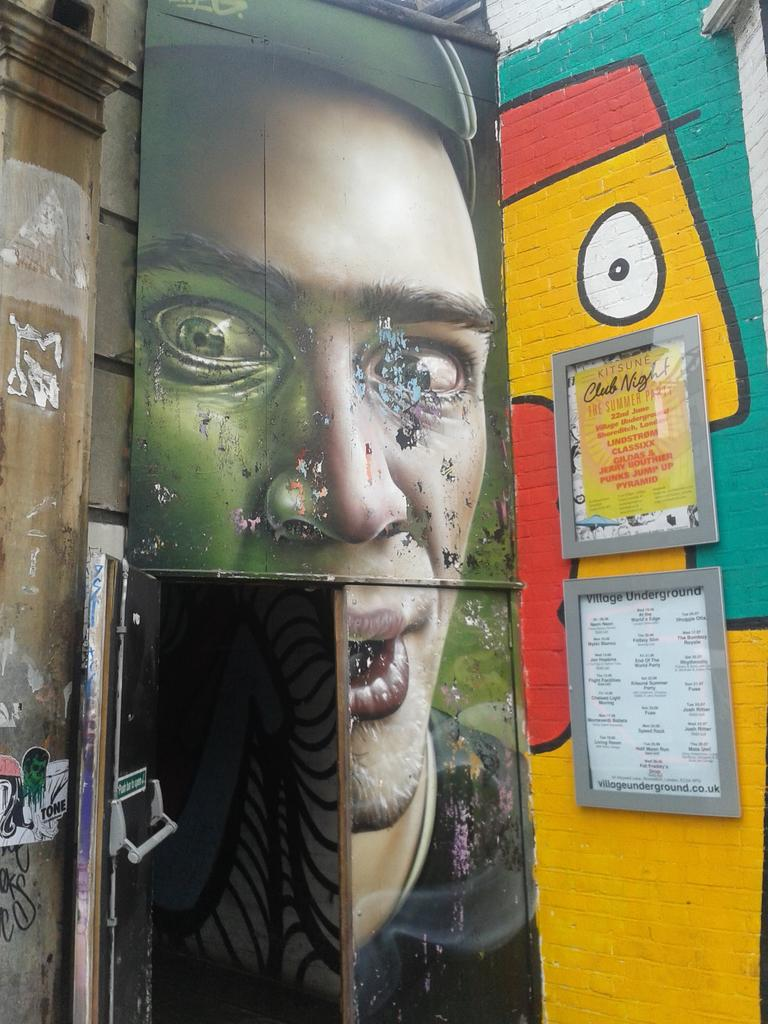What is the main subject in the center of the image? There is a door in the center of the image. What is located beside the door? There is a wall beside the door. What can be seen on the wall? The wall has photo frames on it. How many beds are visible in the image? There are no beds visible in the image. What type of quartz can be seen in the photo frames? There is no quartz present in the image; the photo frames are not described as containing any specific materials. 